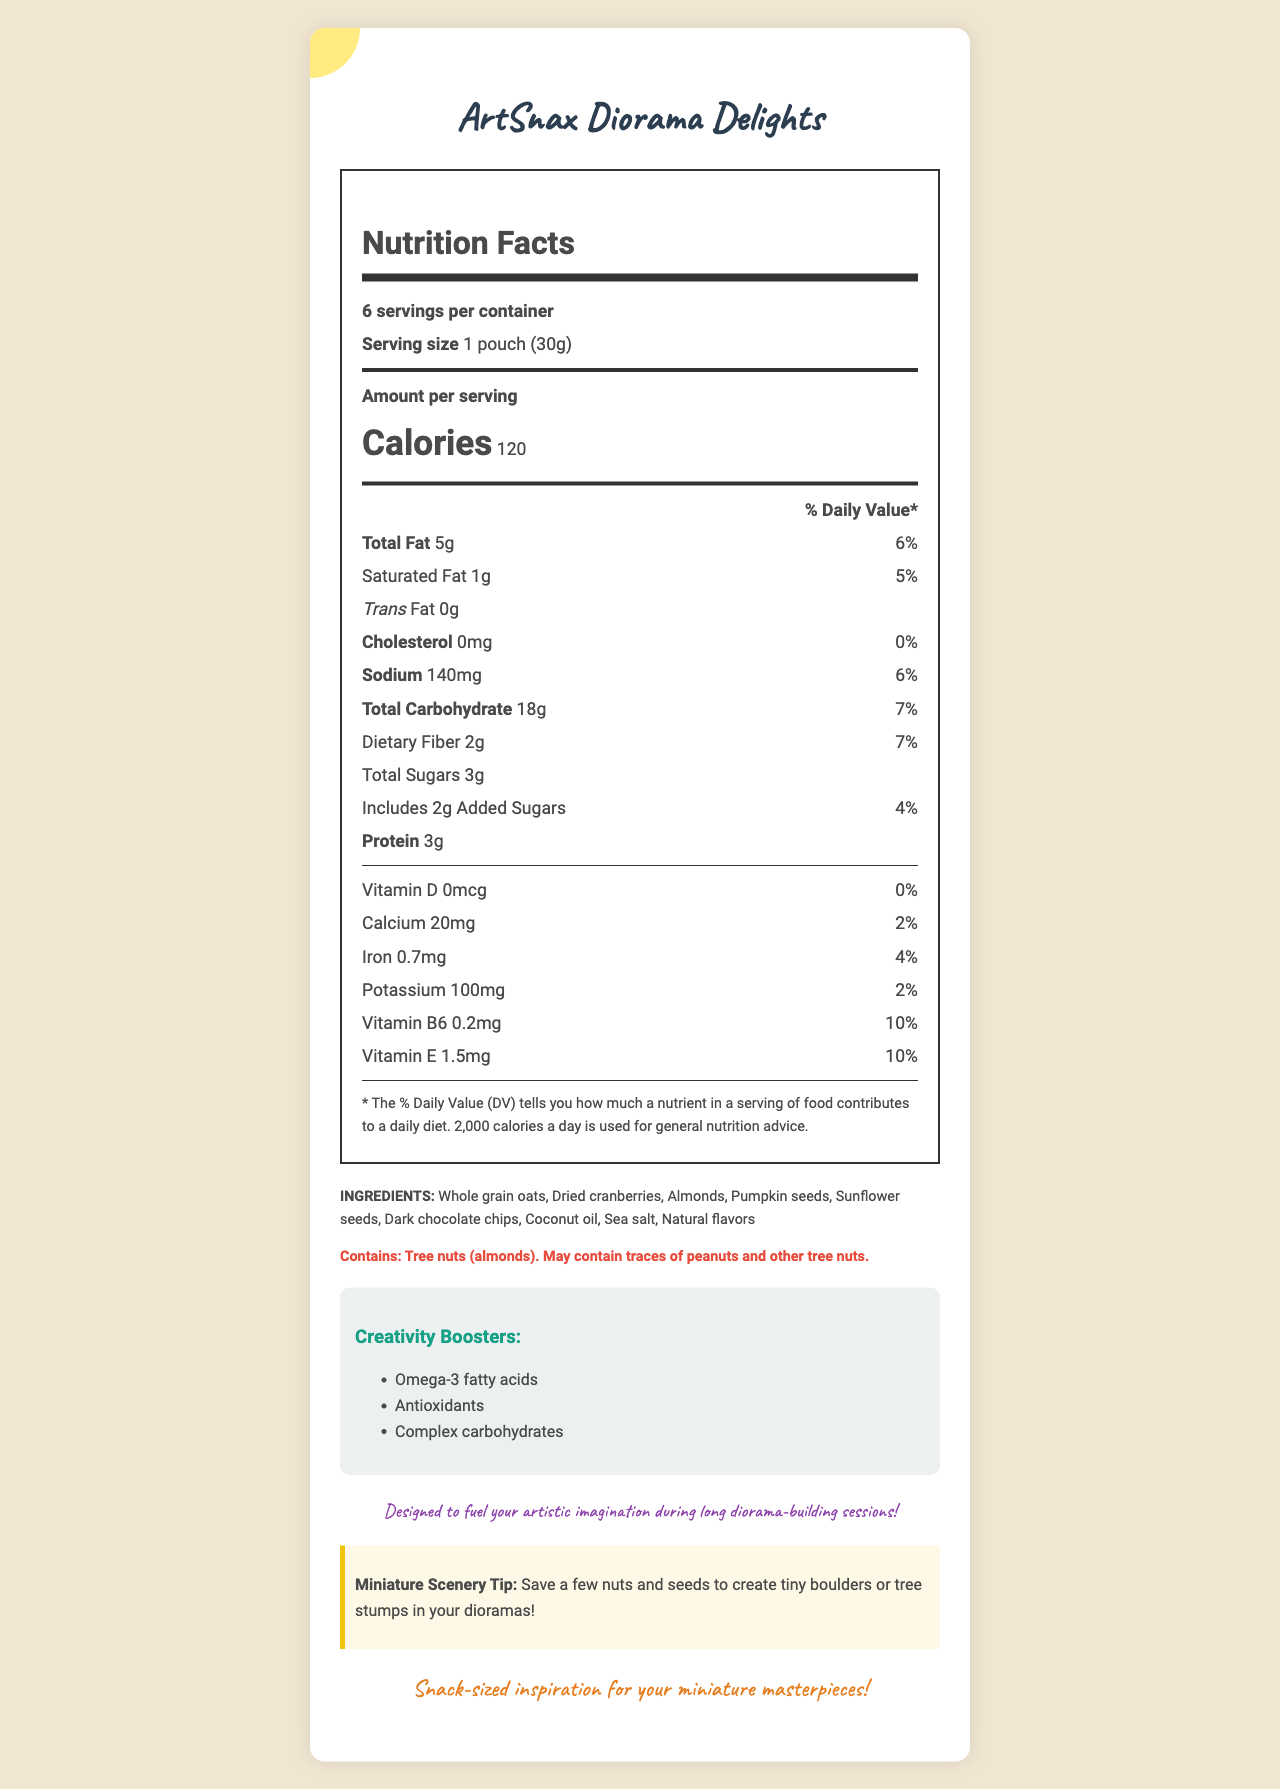what is the product name? The product name is located at the top of the document, in a large, decorative font.
Answer: ArtSnax Diorama Delights what is the serving size of ArtSnax Diorama Delights? The serving size is mentioned right under the "Nutrition Facts" heading.
Answer: 1 pouch (30g) how many servings are there per container? The number of servings per container is listed as "6 servings per container."
Answer: 6 how many total calories are there in one serving? The calorie count per serving is noted under "Amount per serving."
Answer: 120 how much protein is in a serving of ArtSnax Diorama Delights? The protein content is listed with a value of 3g.
Answer: 3g how much total fat does one serving of ArtSnax Diorama Delights contain? A. 5g B. 6g C. 7g D. 8g It is mentioned that each serving contains 5g of total fat.
Answer: A. 5g what are the ingredients of ArtSnax Diorama Delights? A. Whole grain oats, Dried cranberries, Almonds, Pumpkin seeds, Sunflower seeds, Dark chocolate chips, Coconut oil, Sea salt, Natural flavors B. Whole grain oats, Almonds, Pumpkin seeds, Butter, Natural flavors C. Corn flakes, Dried cranberries, Almonds, Pumpkin seeds, Sunflower seeds, Dark chocolate chips, Coconut oil, Sea salt, Natural flavors The ingredients list on the document matches option A.
Answer: A. Whole grain oats, Dried cranberries, Almonds, Pumpkin seeds, Sunflower seeds, Dark chocolate chips, Coconut oil, Sea salt, Natural flavors does this product contain peanuts? The allergen information specifies that the product may contain traces of peanuts.
Answer: May contain traces of peanuts how much dietary fiber is in one serving? The dietary fiber content per serving is listed as 2g.
Answer: 2g what are the creativity boosters included in the product? These creativity boosters are listed in the Creativity Boosters section.
Answer: Omega-3 fatty acids, Antioxidants, Complex carbohydrates is there any saturated fat in ArtSnax Diorama Delights? The document states that there is 1g of saturated fat per serving.
Answer: Yes describe the entire document. The document combines nutritional information with creative suggestions, indicating its multi-functional purpose.
Answer: The document provides a detailed nutritional breakdown of ArtSnax Diorama Delights, highlighting its suitability for fueling creativity during diorama-building sessions. It includes nutrition facts such as calories, fat, cholesterol, and proteins, along with a list of ingredients, allergen information, creativity boosters, and special notes and tips for art teachers. what is the product slogan? The slogan is located at the bottom of the document, written in a prominent and stylized font.
Answer: Snack-sized inspiration for your miniature masterpieces! does this product have any vitamin D? The document specifies that there is 0mcg of vitamin D, which translates to 0% of the daily value.
Answer: No what artistic tip does the document give for diorama-building? There is a special "Miniature Scenery Tip" section that provides this useful information.
Answer: Save a few nuts and seeds to create tiny boulders or tree stumps in your dioramas! where is the calorie information located? The calorie count is prominently displayed below "Amount per serving" with a larger font size.
Answer: Below the "Amount per serving" heading, in large, bold text how much iron does one serving contain? The information shows that one serving contains 0.7mg of iron.
Answer: 0.7mg what is the daily value percentage for vitamin E in one serving? The document indicates that one serving contains 10% of the daily value for vitamin E.
Answer: 10% what is the main idea of the document? The document provides multiple types of information about the snack, highlighting its nutritional value, creative benefits, and suitability for diorama-building sessions.
Answer: A nutritional and creative guide for ArtSnax Diorama Delights, which are snacks intended to fuel creativity during long diorama-building sessions. is the serving size information located near the top of the document? The serving size information is situated right under the "Nutrition Facts" heading.
Answer: Yes 